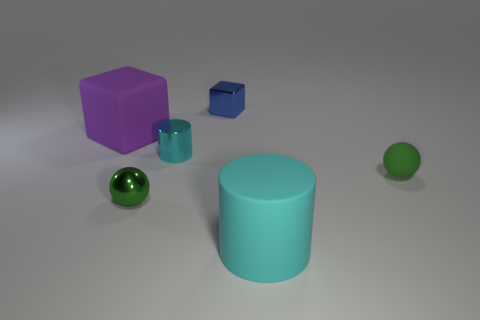What number of other big cylinders are the same material as the large cylinder?
Provide a succinct answer. 0. What number of small red metal balls are there?
Ensure brevity in your answer.  0. Do the big object in front of the tiny green metal sphere and the cylinder behind the tiny green rubber thing have the same color?
Your answer should be compact. Yes. How many big matte cylinders are to the left of the cyan matte cylinder?
Give a very brief answer. 0. There is a big object that is the same color as the metal cylinder; what is its material?
Offer a very short reply. Rubber. Is there a small green shiny object of the same shape as the tiny blue object?
Your answer should be compact. No. Is the material of the sphere that is on the right side of the tiny green metallic ball the same as the cylinder left of the tiny blue block?
Provide a short and direct response. No. How big is the green sphere that is right of the cyan cylinder behind the large object that is on the right side of the tiny metallic cube?
Provide a short and direct response. Small. What is the material of the other green thing that is the same size as the green metal object?
Your answer should be very brief. Rubber. Are there any cyan metallic balls that have the same size as the blue shiny thing?
Make the answer very short. No. 